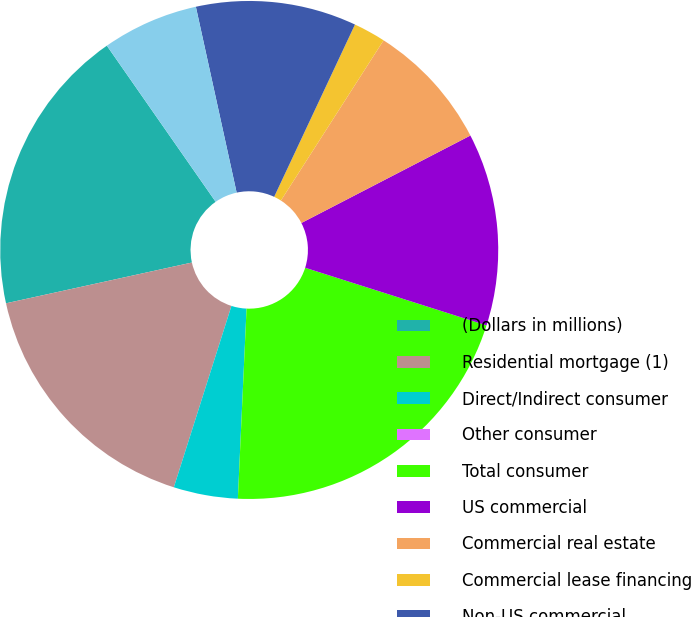<chart> <loc_0><loc_0><loc_500><loc_500><pie_chart><fcel>(Dollars in millions)<fcel>Residential mortgage (1)<fcel>Direct/Indirect consumer<fcel>Other consumer<fcel>Total consumer<fcel>US commercial<fcel>Commercial real estate<fcel>Commercial lease financing<fcel>Non-US commercial<fcel>US small business commercial<nl><fcel>18.75%<fcel>16.67%<fcel>4.17%<fcel>0.0%<fcel>20.83%<fcel>12.5%<fcel>8.33%<fcel>2.09%<fcel>10.42%<fcel>6.25%<nl></chart> 